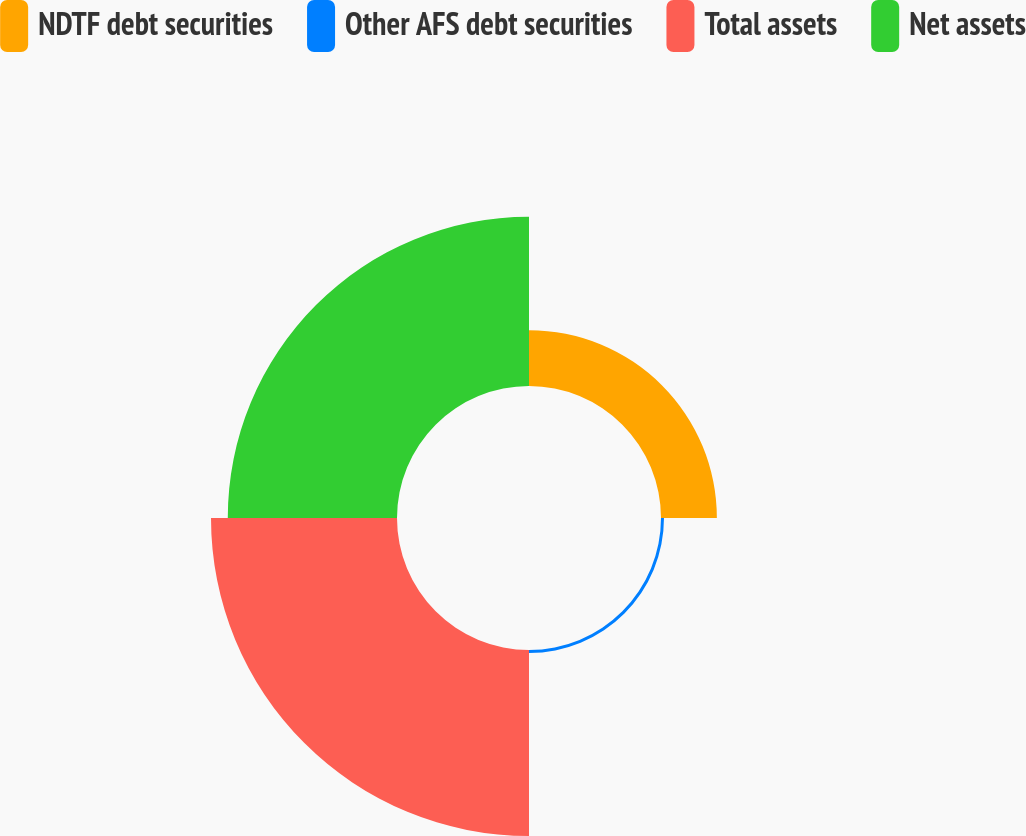Convert chart. <chart><loc_0><loc_0><loc_500><loc_500><pie_chart><fcel>NDTF debt securities<fcel>Other AFS debt securities<fcel>Total assets<fcel>Net assets<nl><fcel>13.49%<fcel>0.72%<fcel>44.92%<fcel>40.87%<nl></chart> 